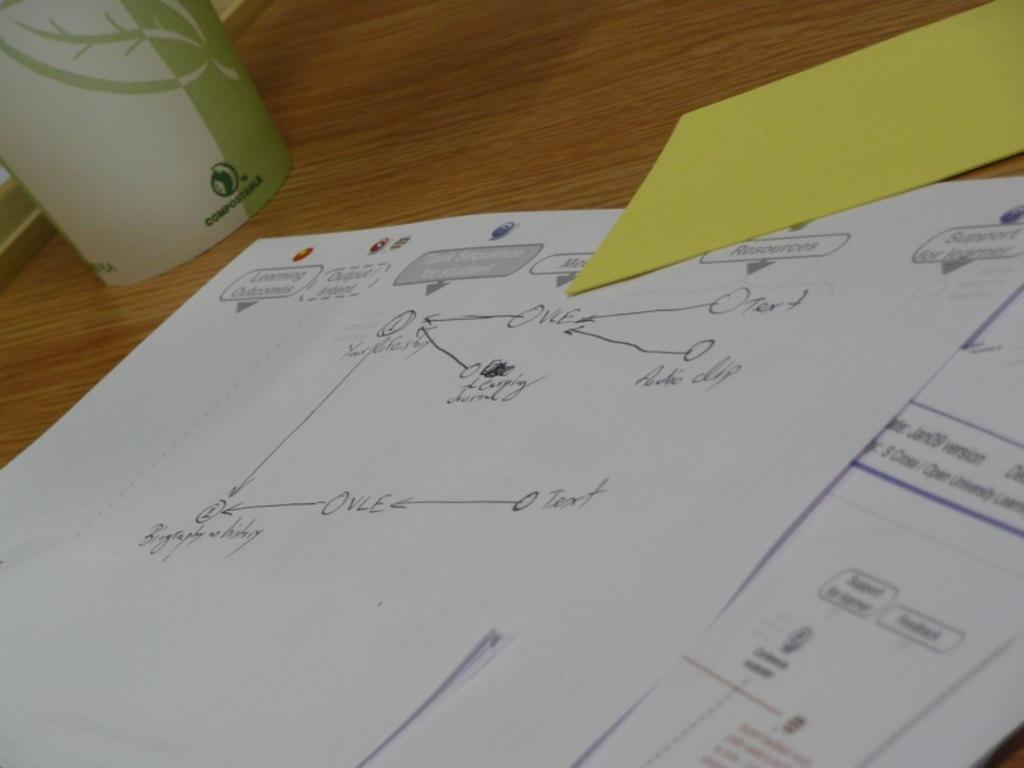What is connected to the audio clip?
Give a very brief answer. Vle. 